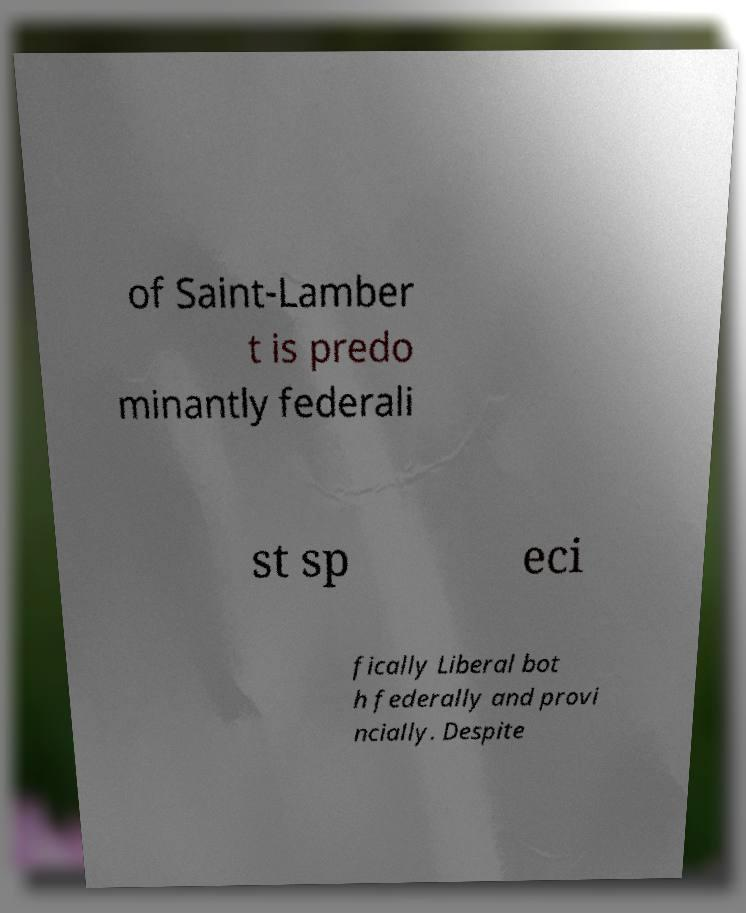For documentation purposes, I need the text within this image transcribed. Could you provide that? of Saint-Lamber t is predo minantly federali st sp eci fically Liberal bot h federally and provi ncially. Despite 